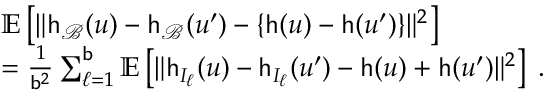<formula> <loc_0><loc_0><loc_500><loc_500>\begin{array} { r l } & { \mathbb { E } \left [ \| h _ { \mathcal { B } } ( u ) - h _ { \mathcal { B } } ( u ^ { \prime } ) - \{ h ( u ) - h ( u ^ { \prime } ) \} \| ^ { 2 } \right ] } \\ & { = \frac { 1 } { b ^ { 2 } } \sum _ { \ell = 1 } ^ { b } \mathbb { E } \left [ \| h _ { I _ { \ell } } ( u ) - h _ { I _ { \ell } } ( u ^ { \prime } ) - h ( u ) + h ( u ^ { \prime } ) \| ^ { 2 } \right ] \, . } \end{array}</formula> 